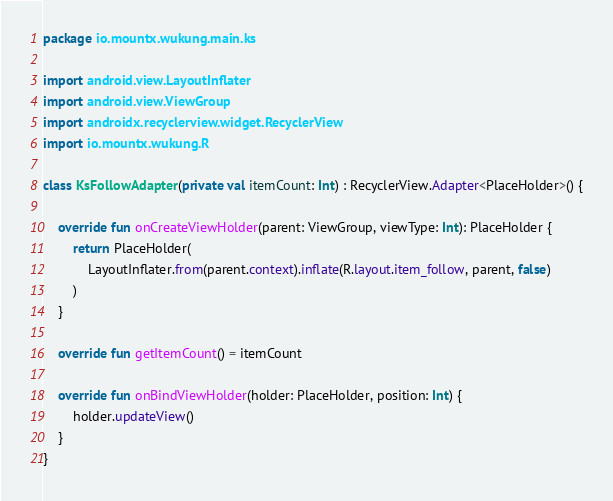<code> <loc_0><loc_0><loc_500><loc_500><_Kotlin_>package io.mountx.wukung.main.ks

import android.view.LayoutInflater
import android.view.ViewGroup
import androidx.recyclerview.widget.RecyclerView
import io.mountx.wukung.R

class KsFollowAdapter(private val itemCount: Int) : RecyclerView.Adapter<PlaceHolder>() {

    override fun onCreateViewHolder(parent: ViewGroup, viewType: Int): PlaceHolder {
        return PlaceHolder(
            LayoutInflater.from(parent.context).inflate(R.layout.item_follow, parent, false)
        )
    }

    override fun getItemCount() = itemCount

    override fun onBindViewHolder(holder: PlaceHolder, position: Int) {
        holder.updateView()
    }
}</code> 